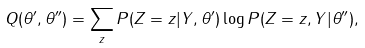Convert formula to latex. <formula><loc_0><loc_0><loc_500><loc_500>Q ( \theta ^ { \prime } , \theta ^ { \prime \prime } ) & = \sum _ { z } P ( Z = z | Y , \theta ^ { \prime } ) \log P ( Z = z , Y | \theta ^ { \prime \prime } ) ,</formula> 